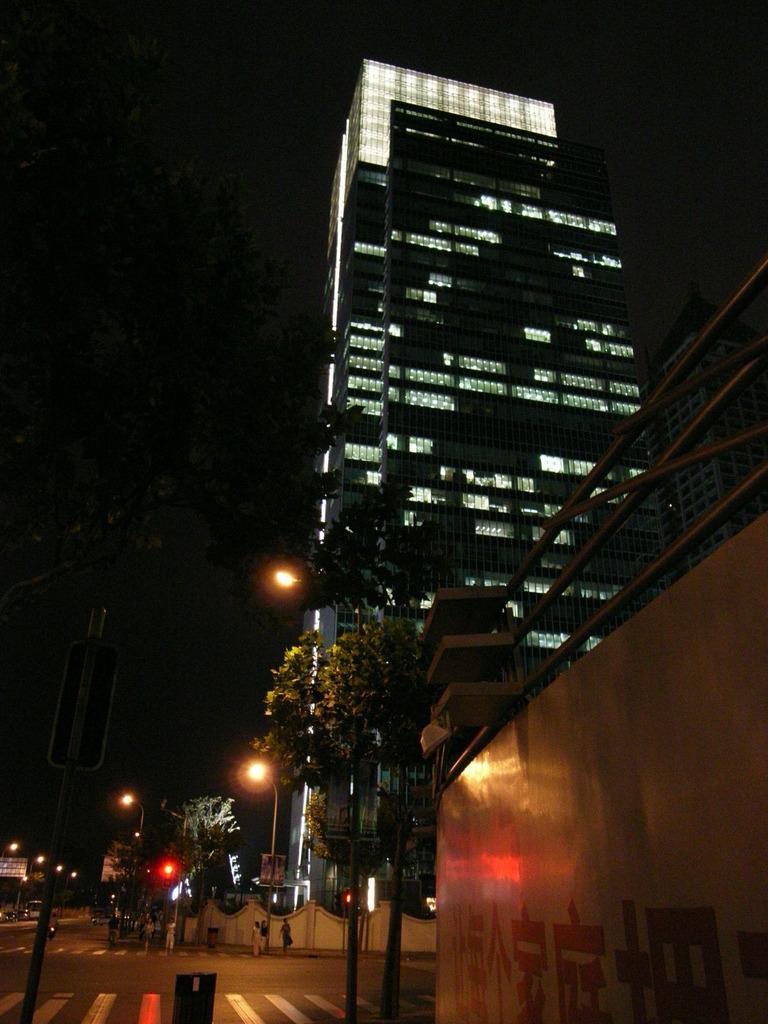Please provide a concise description of this image. In the center of the image we can see an electric light poles and some persons, trees are present. On the right side of the image we can see a building. At the bottom of the image a road is present. At the top of the image sky is there. At the bottom right corner wall and rods are present. 